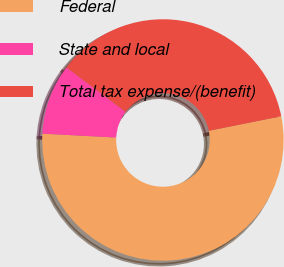<chart> <loc_0><loc_0><loc_500><loc_500><pie_chart><fcel>Federal<fcel>State and local<fcel>Total tax expense/(benefit)<nl><fcel>53.98%<fcel>9.43%<fcel>36.59%<nl></chart> 